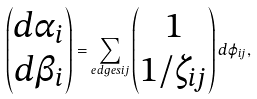Convert formula to latex. <formula><loc_0><loc_0><loc_500><loc_500>\begin{pmatrix} d \alpha _ { i } \\ d \beta _ { i } \end{pmatrix} = \sum _ { e d g e s i j } \begin{pmatrix} 1 \\ 1 / \zeta _ { i j } \end{pmatrix} d \varphi _ { i j } ,</formula> 